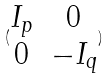Convert formula to latex. <formula><loc_0><loc_0><loc_500><loc_500>( \begin{matrix} I _ { p } & 0 \\ 0 & - I _ { q } \end{matrix} )</formula> 